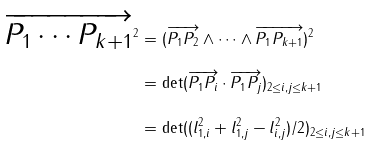<formula> <loc_0><loc_0><loc_500><loc_500>\overrightarrow { P _ { 1 } \cdots P _ { k + 1 } } ^ { 2 } & = ( \overrightarrow { P _ { 1 } P _ { 2 } } \wedge \cdots \wedge \overrightarrow { P _ { 1 } P _ { k + 1 } } ) ^ { 2 } \\ & = \det ( \overrightarrow { P _ { 1 } P _ { i } } \cdot \overrightarrow { P _ { 1 } P _ { j } } ) _ { 2 \leq i , j \leq k + 1 } \\ & = \det ( ( l _ { 1 , i } ^ { 2 } + l _ { 1 , j } ^ { 2 } - l _ { i , j } ^ { 2 } ) / 2 ) _ { 2 \leq i , j \leq k + 1 } \\</formula> 